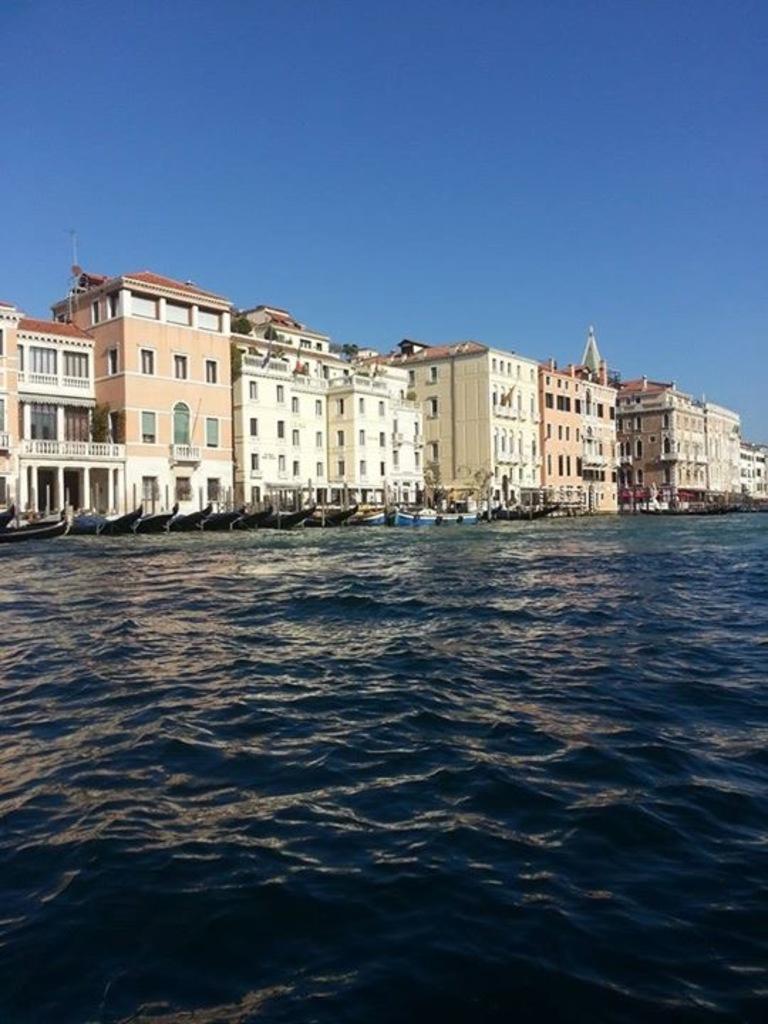Could you give a brief overview of what you see in this image? This is water, in the middle there are boats and these are the buildings. 